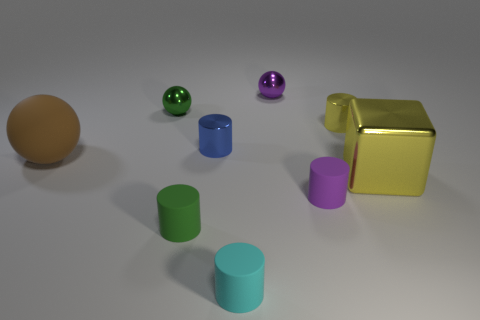Subtract all small green balls. How many balls are left? 2 Add 1 small blue metal blocks. How many objects exist? 10 Subtract all blocks. How many objects are left? 8 Subtract all blue cylinders. How many purple spheres are left? 1 Add 7 small green rubber objects. How many small green rubber objects are left? 8 Add 4 brown spheres. How many brown spheres exist? 5 Subtract all purple cylinders. How many cylinders are left? 4 Subtract 1 purple cylinders. How many objects are left? 8 Subtract 3 cylinders. How many cylinders are left? 2 Subtract all blue cylinders. Subtract all brown spheres. How many cylinders are left? 4 